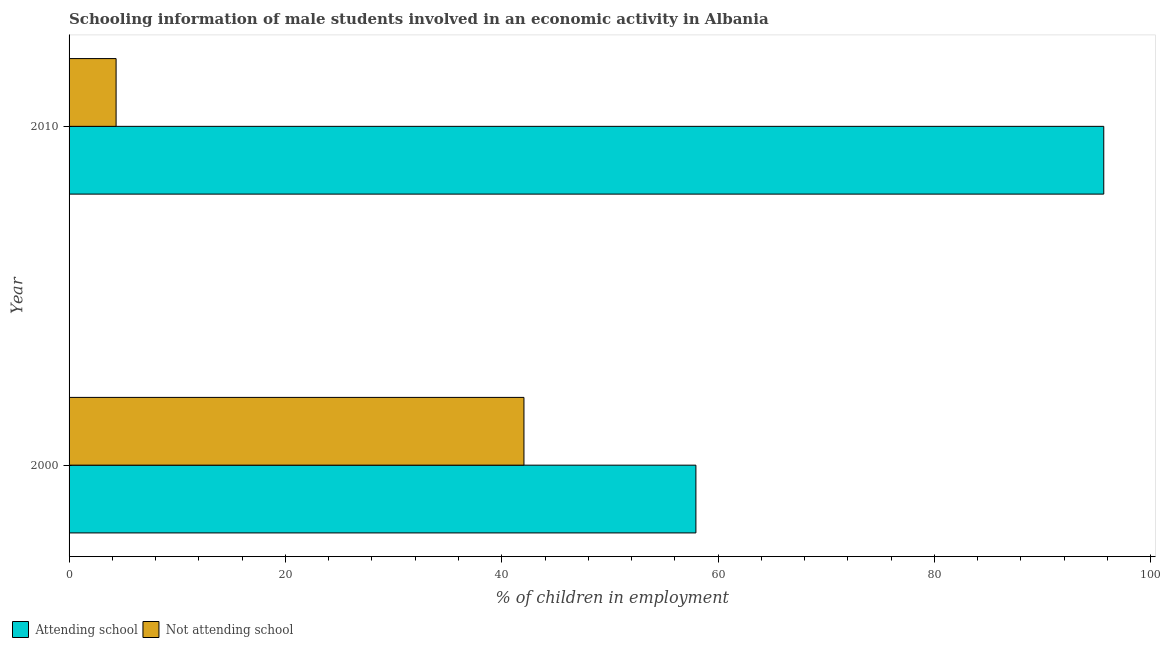How many groups of bars are there?
Provide a short and direct response. 2. What is the percentage of employed males who are not attending school in 2010?
Ensure brevity in your answer.  4.35. Across all years, what is the maximum percentage of employed males who are not attending school?
Offer a very short reply. 42.05. Across all years, what is the minimum percentage of employed males who are attending school?
Offer a terse response. 57.95. In which year was the percentage of employed males who are not attending school minimum?
Make the answer very short. 2010. What is the total percentage of employed males who are not attending school in the graph?
Your answer should be very brief. 46.4. What is the difference between the percentage of employed males who are attending school in 2000 and that in 2010?
Your response must be concise. -37.7. What is the difference between the percentage of employed males who are not attending school in 2000 and the percentage of employed males who are attending school in 2010?
Keep it short and to the point. -53.6. What is the average percentage of employed males who are not attending school per year?
Make the answer very short. 23.2. In the year 2000, what is the difference between the percentage of employed males who are not attending school and percentage of employed males who are attending school?
Provide a short and direct response. -15.9. What is the ratio of the percentage of employed males who are attending school in 2000 to that in 2010?
Your answer should be very brief. 0.61. Is the percentage of employed males who are attending school in 2000 less than that in 2010?
Provide a short and direct response. Yes. Is the difference between the percentage of employed males who are attending school in 2000 and 2010 greater than the difference between the percentage of employed males who are not attending school in 2000 and 2010?
Ensure brevity in your answer.  No. In how many years, is the percentage of employed males who are not attending school greater than the average percentage of employed males who are not attending school taken over all years?
Provide a short and direct response. 1. What does the 2nd bar from the top in 2010 represents?
Your answer should be compact. Attending school. What does the 2nd bar from the bottom in 2010 represents?
Keep it short and to the point. Not attending school. How many bars are there?
Your response must be concise. 4. How many years are there in the graph?
Provide a short and direct response. 2. Does the graph contain any zero values?
Offer a very short reply. No. Does the graph contain grids?
Give a very brief answer. No. Where does the legend appear in the graph?
Keep it short and to the point. Bottom left. How are the legend labels stacked?
Your answer should be very brief. Horizontal. What is the title of the graph?
Provide a short and direct response. Schooling information of male students involved in an economic activity in Albania. What is the label or title of the X-axis?
Provide a short and direct response. % of children in employment. What is the label or title of the Y-axis?
Keep it short and to the point. Year. What is the % of children in employment in Attending school in 2000?
Ensure brevity in your answer.  57.95. What is the % of children in employment of Not attending school in 2000?
Offer a terse response. 42.05. What is the % of children in employment of Attending school in 2010?
Your response must be concise. 95.65. What is the % of children in employment of Not attending school in 2010?
Your answer should be very brief. 4.35. Across all years, what is the maximum % of children in employment in Attending school?
Make the answer very short. 95.65. Across all years, what is the maximum % of children in employment in Not attending school?
Offer a very short reply. 42.05. Across all years, what is the minimum % of children in employment of Attending school?
Your answer should be very brief. 57.95. Across all years, what is the minimum % of children in employment of Not attending school?
Your answer should be compact. 4.35. What is the total % of children in employment of Attending school in the graph?
Make the answer very short. 153.6. What is the total % of children in employment in Not attending school in the graph?
Your answer should be compact. 46.4. What is the difference between the % of children in employment in Attending school in 2000 and that in 2010?
Make the answer very short. -37.7. What is the difference between the % of children in employment of Not attending school in 2000 and that in 2010?
Your answer should be very brief. 37.7. What is the difference between the % of children in employment of Attending school in 2000 and the % of children in employment of Not attending school in 2010?
Offer a very short reply. 53.6. What is the average % of children in employment in Attending school per year?
Provide a short and direct response. 76.8. What is the average % of children in employment of Not attending school per year?
Give a very brief answer. 23.2. In the year 2000, what is the difference between the % of children in employment of Attending school and % of children in employment of Not attending school?
Provide a short and direct response. 15.9. In the year 2010, what is the difference between the % of children in employment in Attending school and % of children in employment in Not attending school?
Provide a short and direct response. 91.31. What is the ratio of the % of children in employment of Attending school in 2000 to that in 2010?
Your response must be concise. 0.61. What is the ratio of the % of children in employment of Not attending school in 2000 to that in 2010?
Provide a short and direct response. 9.67. What is the difference between the highest and the second highest % of children in employment in Attending school?
Give a very brief answer. 37.7. What is the difference between the highest and the second highest % of children in employment in Not attending school?
Provide a succinct answer. 37.7. What is the difference between the highest and the lowest % of children in employment of Attending school?
Offer a terse response. 37.7. What is the difference between the highest and the lowest % of children in employment of Not attending school?
Your answer should be compact. 37.7. 